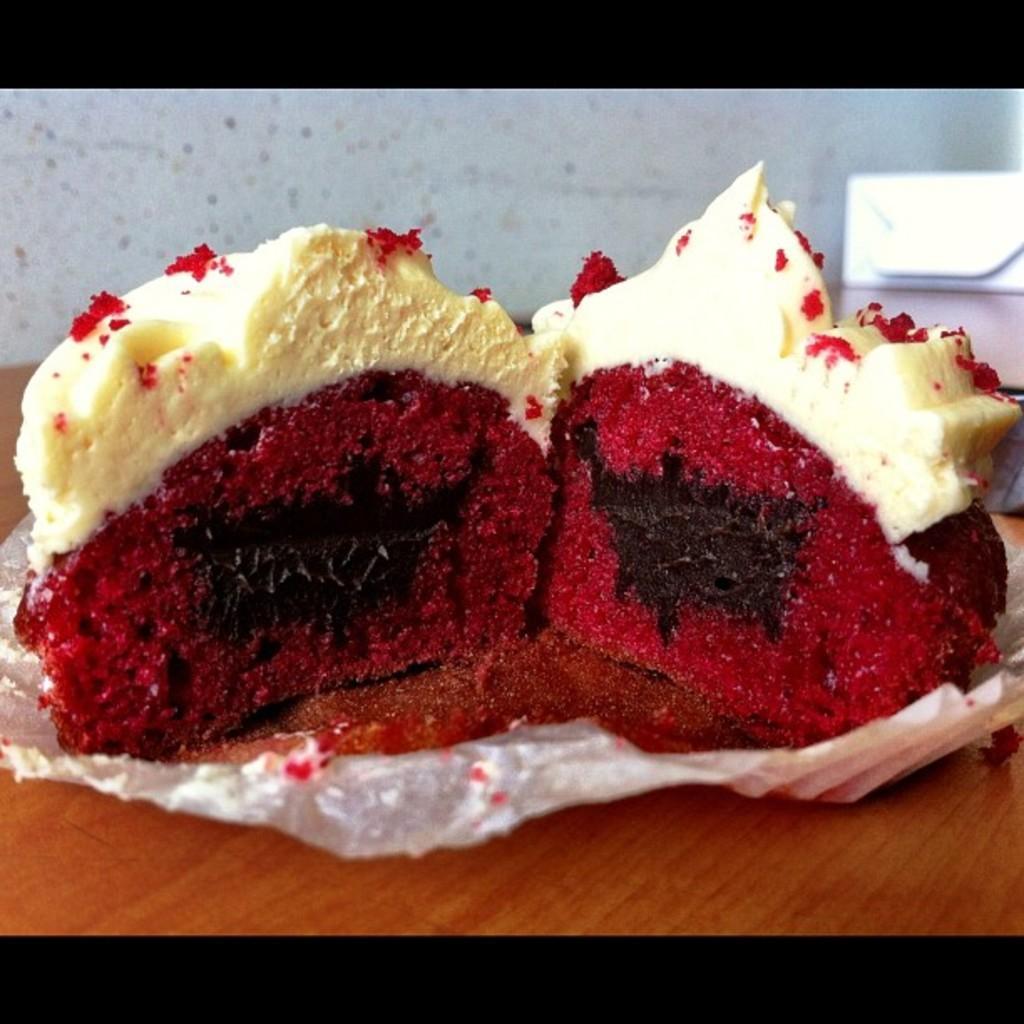In one or two sentences, can you explain what this image depicts? There is a table. On that there is a paper. On the paper there are pieces of cake. 